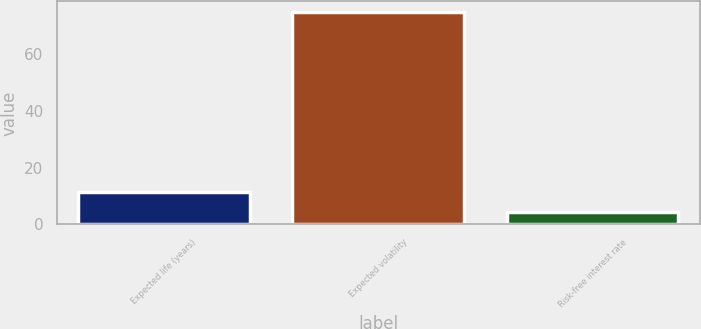<chart> <loc_0><loc_0><loc_500><loc_500><bar_chart><fcel>Expected life (years)<fcel>Expected volatility<fcel>Risk-free interest rate<nl><fcel>11.26<fcel>75<fcel>4.18<nl></chart> 